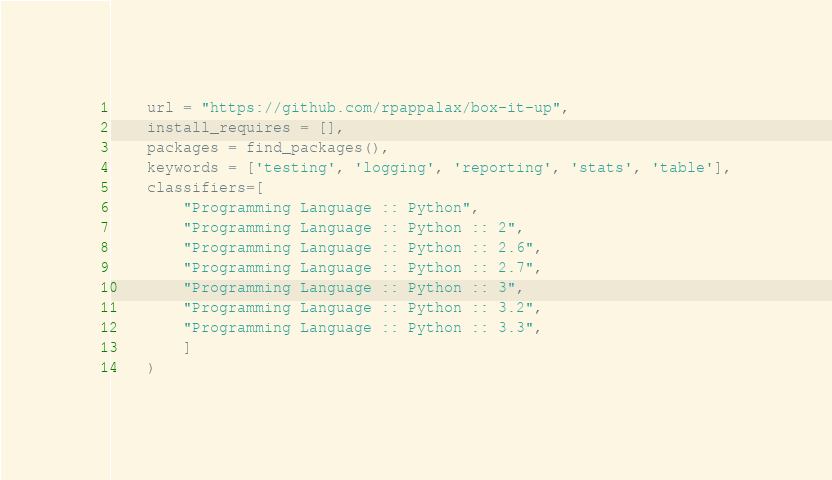Convert code to text. <code><loc_0><loc_0><loc_500><loc_500><_Python_>    url = "https://github.com/rpappalax/box-it-up",
    install_requires = [],
    packages = find_packages(),
    keywords = ['testing', 'logging', 'reporting', 'stats', 'table'],
    classifiers=[
        "Programming Language :: Python",
        "Programming Language :: Python :: 2",
        "Programming Language :: Python :: 2.6",
        "Programming Language :: Python :: 2.7",
        "Programming Language :: Python :: 3",
        "Programming Language :: Python :: 3.2",
        "Programming Language :: Python :: 3.3",
        ]
    )
</code> 